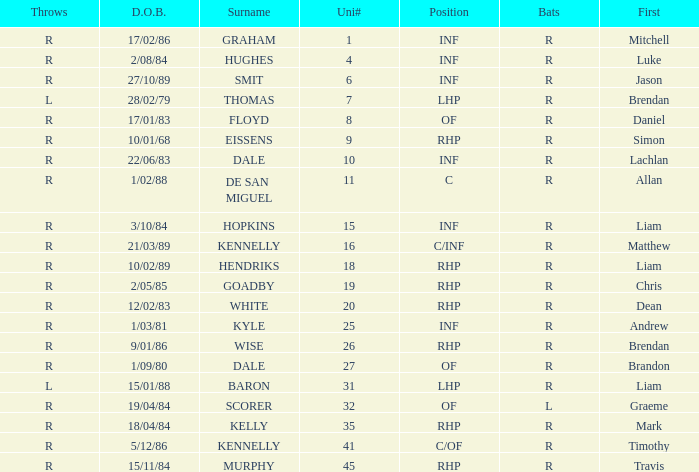Which batter has a uni# of 31? R. 